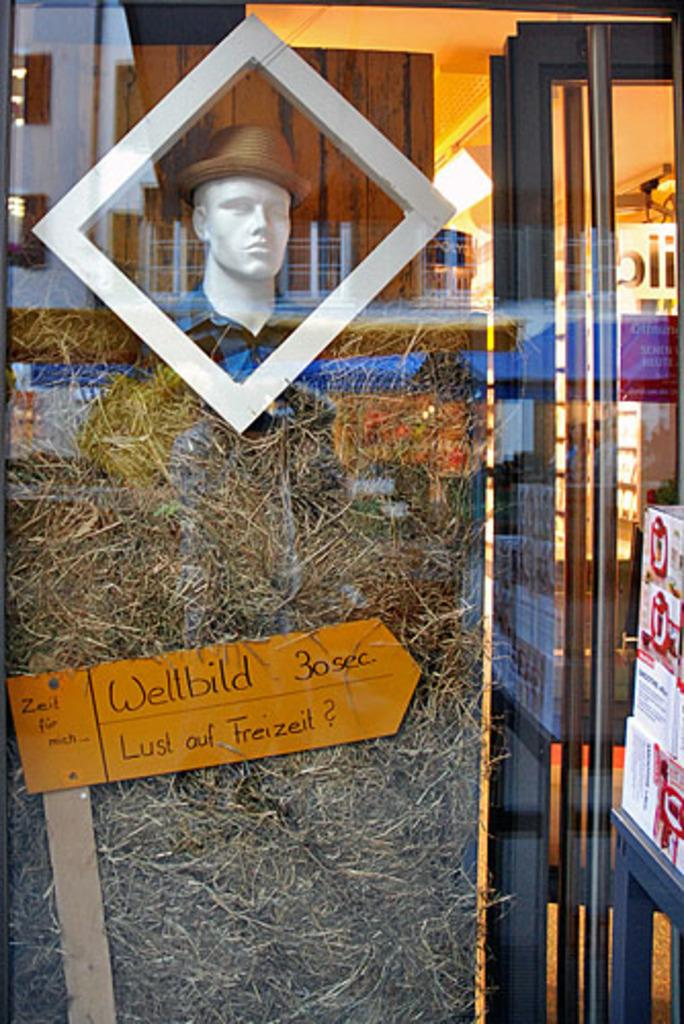What is the main feature in the foreground of the image? There is a glass window in the foreground of the image. What can be seen through the glass window? A manikin, grass, a board, lights, boxes, and a wooden wall are visible through the window. Are there any other objects visible through the window? Yes, there are other unspecified objects visible through the window. What type of guide is the manikin holding in the image? There is no guide visible in the image; the manikin is not holding anything. What color is the skirt on the manikin in the image? There is no skirt visible in the image, as the manikin is not wearing any clothing. 